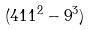<formula> <loc_0><loc_0><loc_500><loc_500>( 4 1 1 ^ { 2 } - 9 ^ { 3 } )</formula> 